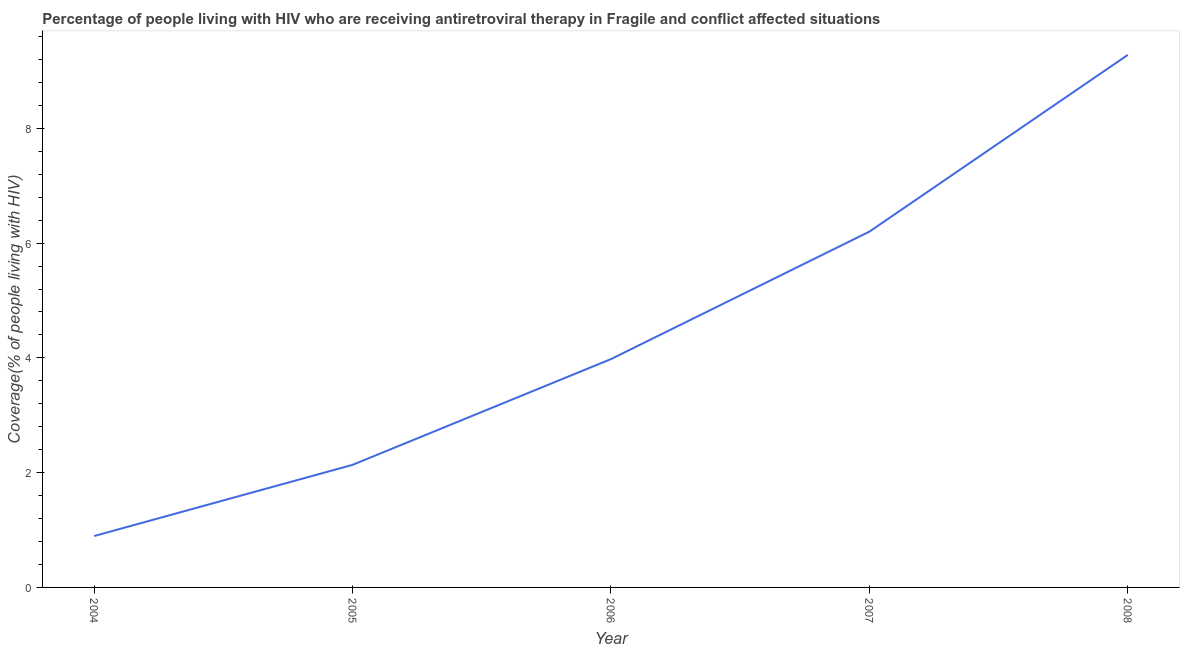What is the antiretroviral therapy coverage in 2005?
Your response must be concise. 2.14. Across all years, what is the maximum antiretroviral therapy coverage?
Make the answer very short. 9.28. Across all years, what is the minimum antiretroviral therapy coverage?
Give a very brief answer. 0.9. What is the sum of the antiretroviral therapy coverage?
Your answer should be very brief. 22.49. What is the difference between the antiretroviral therapy coverage in 2005 and 2006?
Provide a short and direct response. -1.84. What is the average antiretroviral therapy coverage per year?
Your answer should be very brief. 4.5. What is the median antiretroviral therapy coverage?
Ensure brevity in your answer.  3.98. What is the ratio of the antiretroviral therapy coverage in 2004 to that in 2007?
Provide a short and direct response. 0.14. What is the difference between the highest and the second highest antiretroviral therapy coverage?
Your response must be concise. 3.08. Is the sum of the antiretroviral therapy coverage in 2006 and 2008 greater than the maximum antiretroviral therapy coverage across all years?
Ensure brevity in your answer.  Yes. What is the difference between the highest and the lowest antiretroviral therapy coverage?
Offer a very short reply. 8.39. In how many years, is the antiretroviral therapy coverage greater than the average antiretroviral therapy coverage taken over all years?
Offer a terse response. 2. What is the difference between two consecutive major ticks on the Y-axis?
Give a very brief answer. 2. Are the values on the major ticks of Y-axis written in scientific E-notation?
Make the answer very short. No. Does the graph contain any zero values?
Your answer should be compact. No. What is the title of the graph?
Offer a terse response. Percentage of people living with HIV who are receiving antiretroviral therapy in Fragile and conflict affected situations. What is the label or title of the X-axis?
Give a very brief answer. Year. What is the label or title of the Y-axis?
Provide a succinct answer. Coverage(% of people living with HIV). What is the Coverage(% of people living with HIV) of 2004?
Your answer should be very brief. 0.9. What is the Coverage(% of people living with HIV) in 2005?
Provide a short and direct response. 2.14. What is the Coverage(% of people living with HIV) in 2006?
Your answer should be very brief. 3.98. What is the Coverage(% of people living with HIV) of 2007?
Offer a very short reply. 6.2. What is the Coverage(% of people living with HIV) of 2008?
Provide a short and direct response. 9.28. What is the difference between the Coverage(% of people living with HIV) in 2004 and 2005?
Provide a succinct answer. -1.24. What is the difference between the Coverage(% of people living with HIV) in 2004 and 2006?
Your answer should be very brief. -3.08. What is the difference between the Coverage(% of people living with HIV) in 2004 and 2007?
Give a very brief answer. -5.3. What is the difference between the Coverage(% of people living with HIV) in 2004 and 2008?
Provide a short and direct response. -8.39. What is the difference between the Coverage(% of people living with HIV) in 2005 and 2006?
Give a very brief answer. -1.84. What is the difference between the Coverage(% of people living with HIV) in 2005 and 2007?
Your response must be concise. -4.06. What is the difference between the Coverage(% of people living with HIV) in 2005 and 2008?
Offer a very short reply. -7.14. What is the difference between the Coverage(% of people living with HIV) in 2006 and 2007?
Give a very brief answer. -2.22. What is the difference between the Coverage(% of people living with HIV) in 2006 and 2008?
Give a very brief answer. -5.3. What is the difference between the Coverage(% of people living with HIV) in 2007 and 2008?
Provide a short and direct response. -3.08. What is the ratio of the Coverage(% of people living with HIV) in 2004 to that in 2005?
Your response must be concise. 0.42. What is the ratio of the Coverage(% of people living with HIV) in 2004 to that in 2006?
Keep it short and to the point. 0.23. What is the ratio of the Coverage(% of people living with HIV) in 2004 to that in 2007?
Offer a terse response. 0.14. What is the ratio of the Coverage(% of people living with HIV) in 2004 to that in 2008?
Give a very brief answer. 0.1. What is the ratio of the Coverage(% of people living with HIV) in 2005 to that in 2006?
Your answer should be very brief. 0.54. What is the ratio of the Coverage(% of people living with HIV) in 2005 to that in 2007?
Keep it short and to the point. 0.34. What is the ratio of the Coverage(% of people living with HIV) in 2005 to that in 2008?
Your response must be concise. 0.23. What is the ratio of the Coverage(% of people living with HIV) in 2006 to that in 2007?
Provide a succinct answer. 0.64. What is the ratio of the Coverage(% of people living with HIV) in 2006 to that in 2008?
Ensure brevity in your answer.  0.43. What is the ratio of the Coverage(% of people living with HIV) in 2007 to that in 2008?
Offer a very short reply. 0.67. 